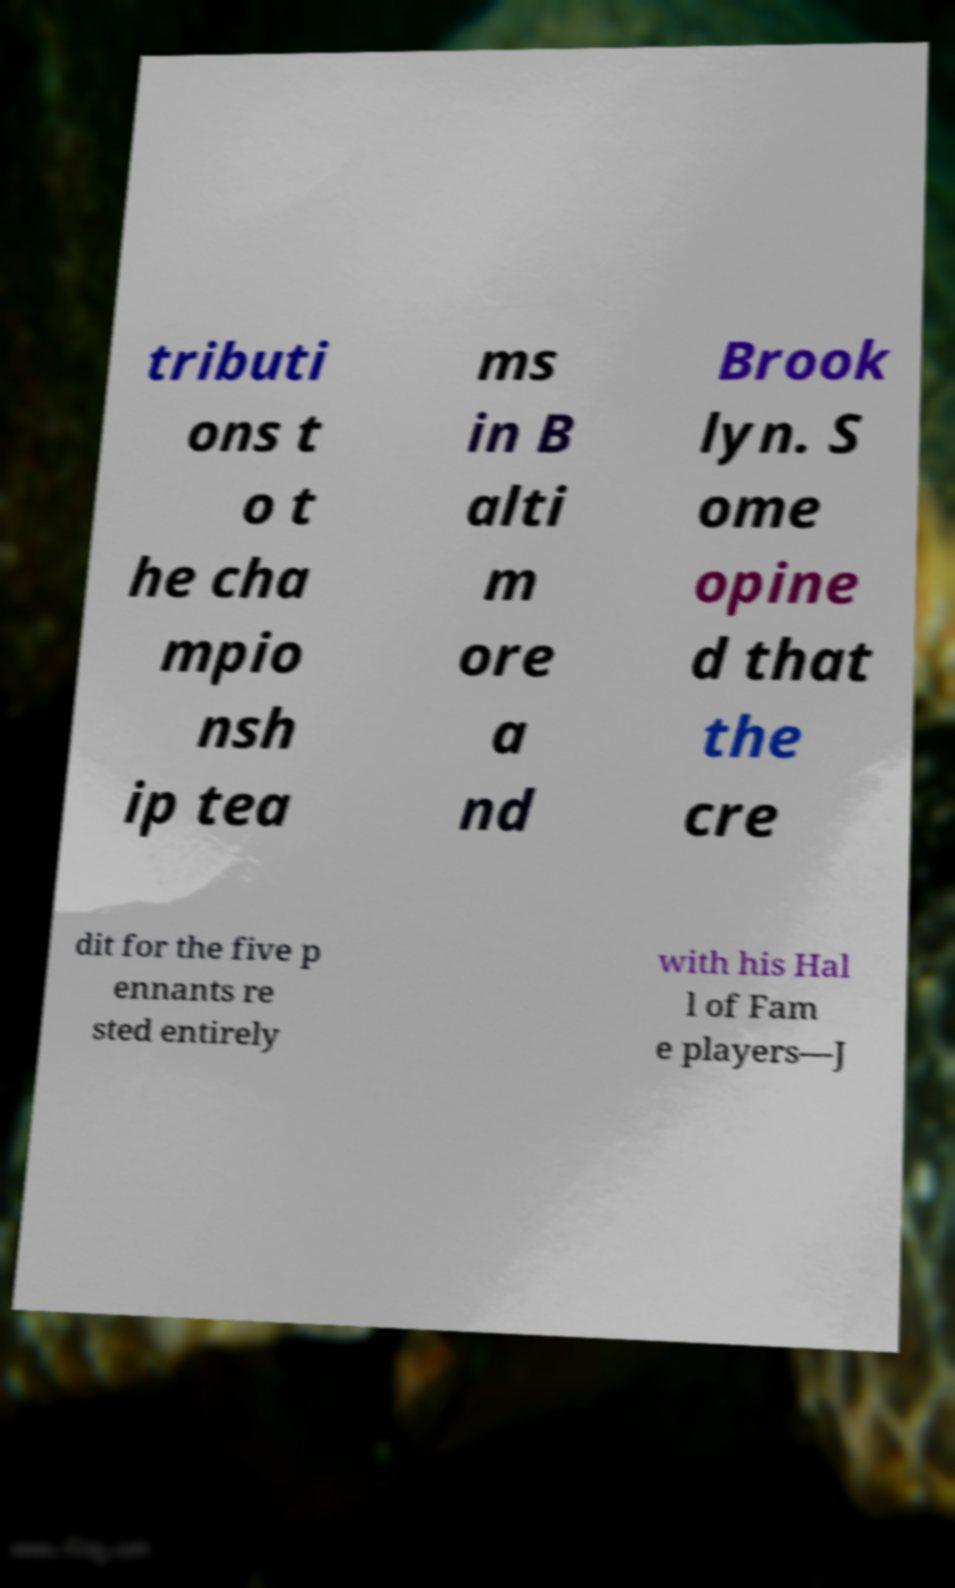What messages or text are displayed in this image? I need them in a readable, typed format. tributi ons t o t he cha mpio nsh ip tea ms in B alti m ore a nd Brook lyn. S ome opine d that the cre dit for the five p ennants re sted entirely with his Hal l of Fam e players—J 